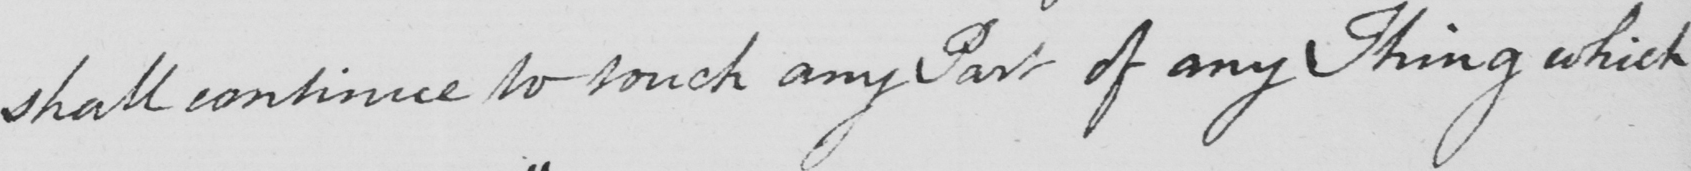What text is written in this handwritten line? shall continue to touch any Part of any Thing which 